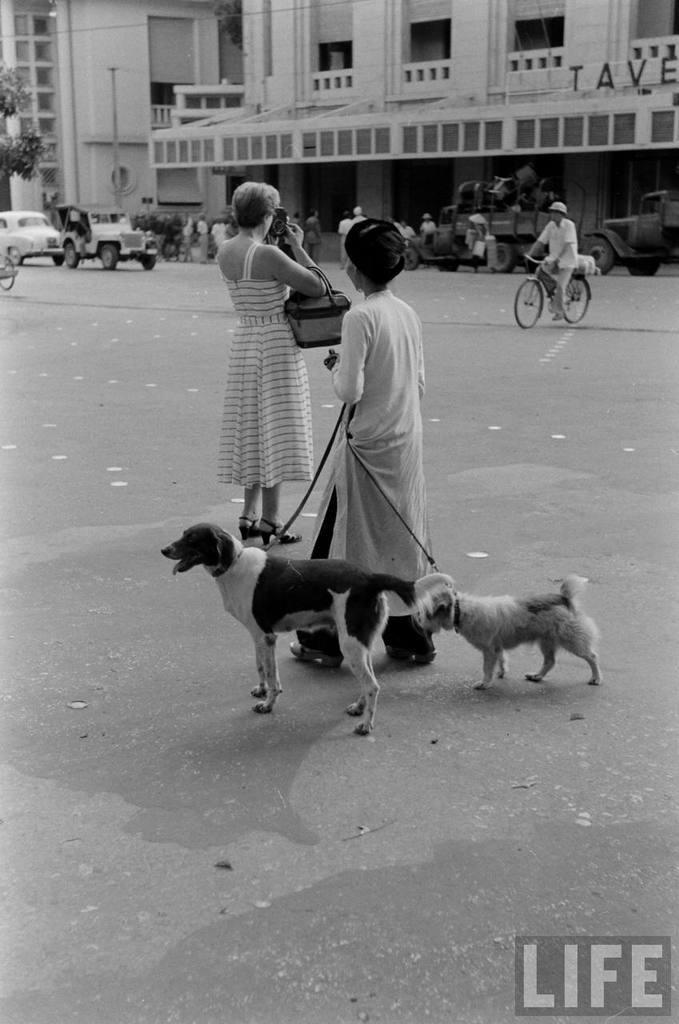Can you describe this image briefly? In the image we can see there are people who are standing on the road and there is a person who is holding dogs on the road and there is a man who is riding a bicycle and behind there is a building and the cars are standing on the road and it's a black and white picture. 